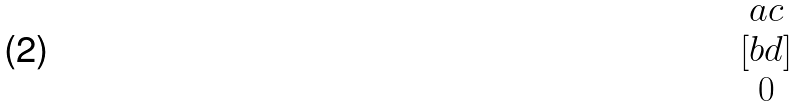<formula> <loc_0><loc_0><loc_500><loc_500>[ \begin{matrix} a c \\ b d \\ 0 \end{matrix} ]</formula> 